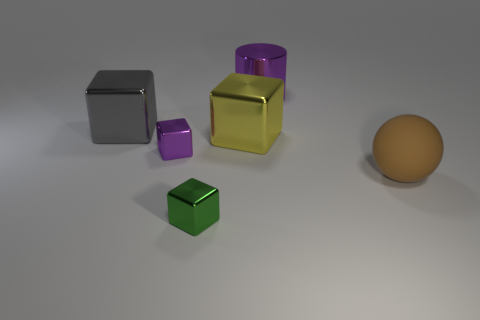Add 1 purple metallic blocks. How many objects exist? 7 Subtract all balls. How many objects are left? 5 Subtract 0 green spheres. How many objects are left? 6 Subtract all brown spheres. Subtract all gray metal blocks. How many objects are left? 4 Add 2 big spheres. How many big spheres are left? 3 Add 4 big brown rubber objects. How many big brown rubber objects exist? 5 